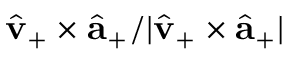<formula> <loc_0><loc_0><loc_500><loc_500>\hat { v } _ { + } \times \hat { \mathbf a } _ { + } / | \hat { v } _ { + } \times \hat { \mathbf a } _ { + } |</formula> 